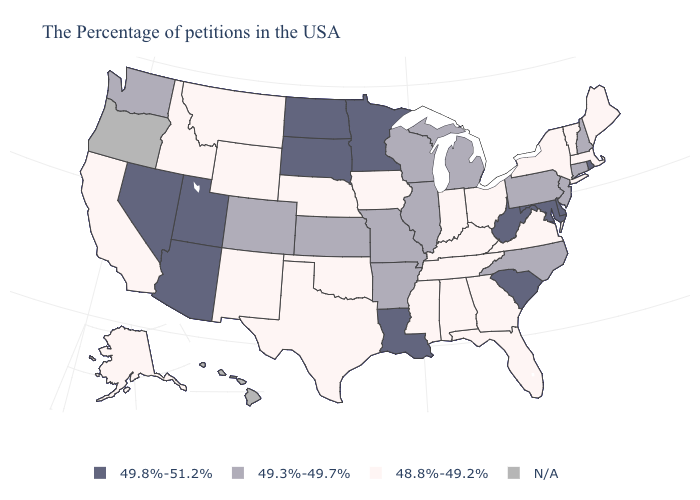Does Vermont have the lowest value in the USA?
Answer briefly. Yes. Name the states that have a value in the range N/A?
Give a very brief answer. Oregon, Hawaii. Name the states that have a value in the range 49.3%-49.7%?
Quick response, please. New Hampshire, Connecticut, New Jersey, Pennsylvania, North Carolina, Michigan, Wisconsin, Illinois, Missouri, Arkansas, Kansas, Colorado, Washington. Which states have the lowest value in the USA?
Answer briefly. Maine, Massachusetts, Vermont, New York, Virginia, Ohio, Florida, Georgia, Kentucky, Indiana, Alabama, Tennessee, Mississippi, Iowa, Nebraska, Oklahoma, Texas, Wyoming, New Mexico, Montana, Idaho, California, Alaska. Does Maryland have the highest value in the USA?
Keep it brief. Yes. What is the value of Illinois?
Give a very brief answer. 49.3%-49.7%. Name the states that have a value in the range 48.8%-49.2%?
Give a very brief answer. Maine, Massachusetts, Vermont, New York, Virginia, Ohio, Florida, Georgia, Kentucky, Indiana, Alabama, Tennessee, Mississippi, Iowa, Nebraska, Oklahoma, Texas, Wyoming, New Mexico, Montana, Idaho, California, Alaska. What is the value of Oregon?
Answer briefly. N/A. Among the states that border Iowa , does Nebraska have the highest value?
Answer briefly. No. What is the highest value in states that border Massachusetts?
Keep it brief. 49.8%-51.2%. Name the states that have a value in the range 49.8%-51.2%?
Answer briefly. Rhode Island, Delaware, Maryland, South Carolina, West Virginia, Louisiana, Minnesota, South Dakota, North Dakota, Utah, Arizona, Nevada. What is the value of Vermont?
Quick response, please. 48.8%-49.2%. 